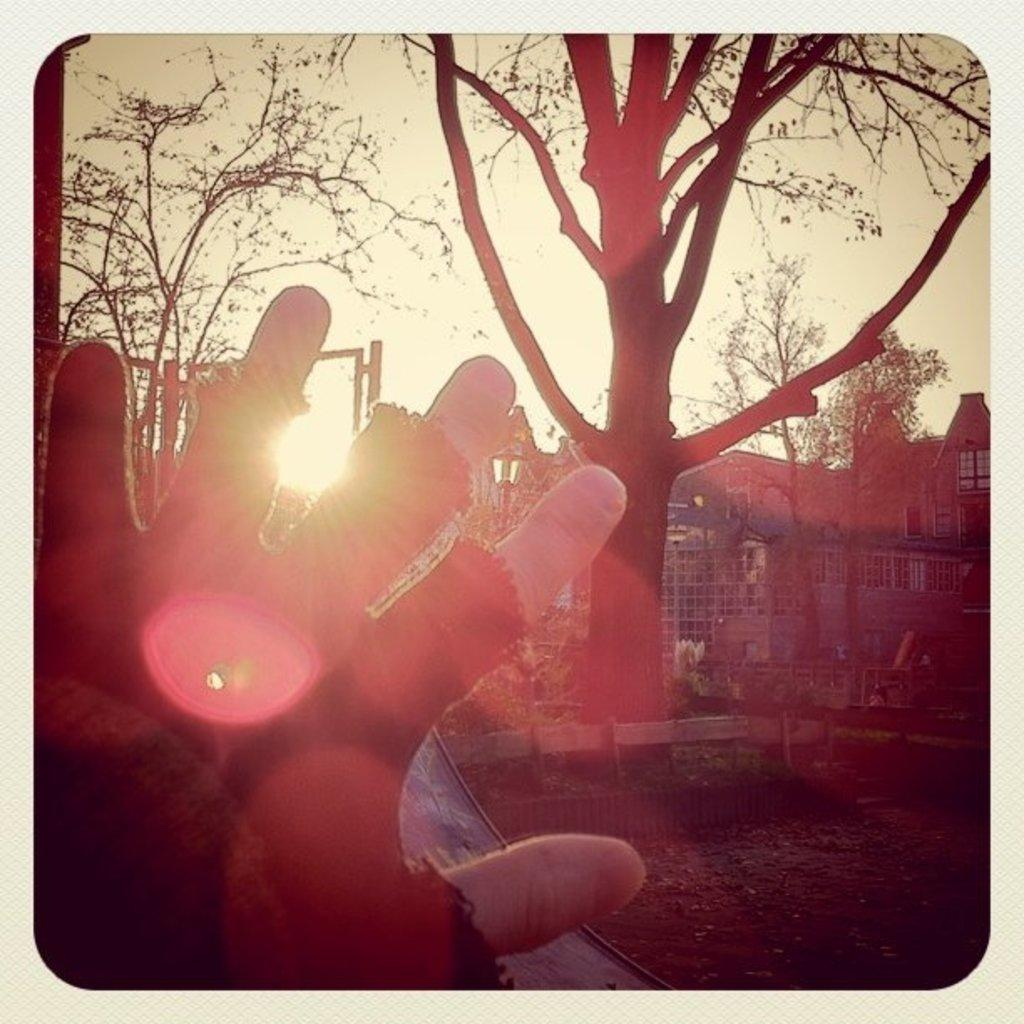What can be observed about the image itself? The image is edited. What is located in the foreground of the image? There is a hand in the foreground of the image. What type of natural environment is visible in the image? There are trees visible in the image. What structure can be seen behind the trees in the image? There is a building behind the trees in the image. What type of playground equipment can be seen in the image? There is no playground equipment present in the image. What suggestion is being made by the hand in the image? The image does not convey any specific suggestion or message; it simply shows a hand in the foreground. 